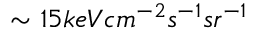<formula> <loc_0><loc_0><loc_500><loc_500>\sim 1 5 k e V c m ^ { - 2 } s ^ { - 1 } s r ^ { - 1 }</formula> 